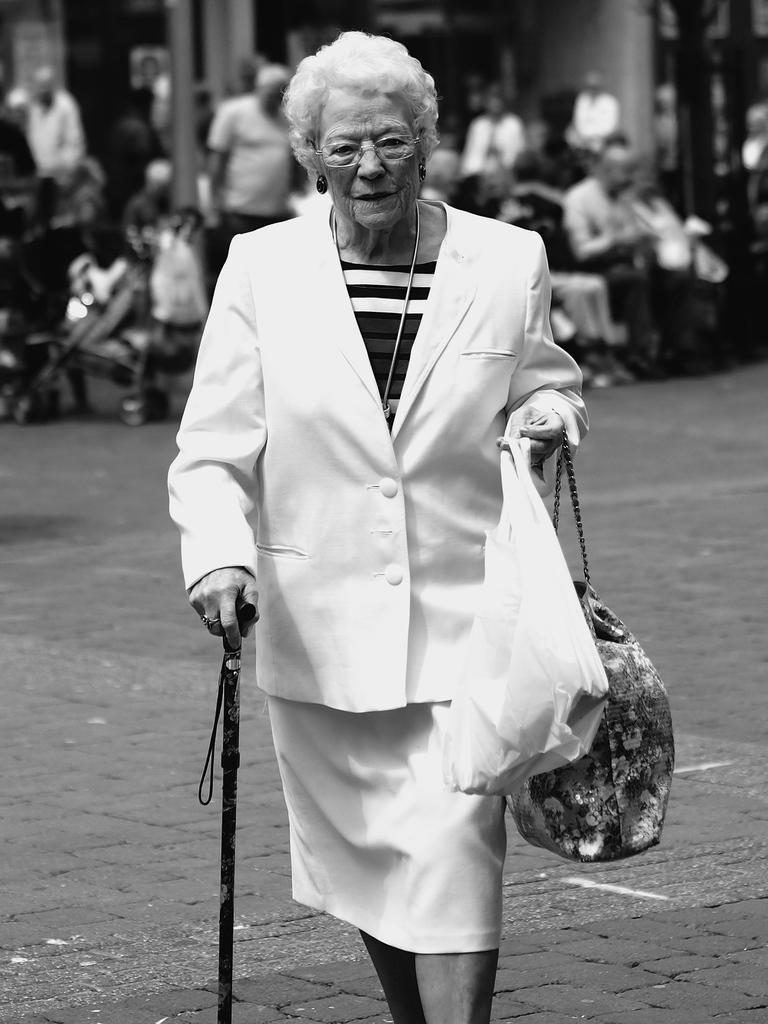Describe this image in one or two sentences. A black and white picture. Front this woman is highlighted in this picture. Far there are many persons That women wore white suit, holding plastic bag and stick. 